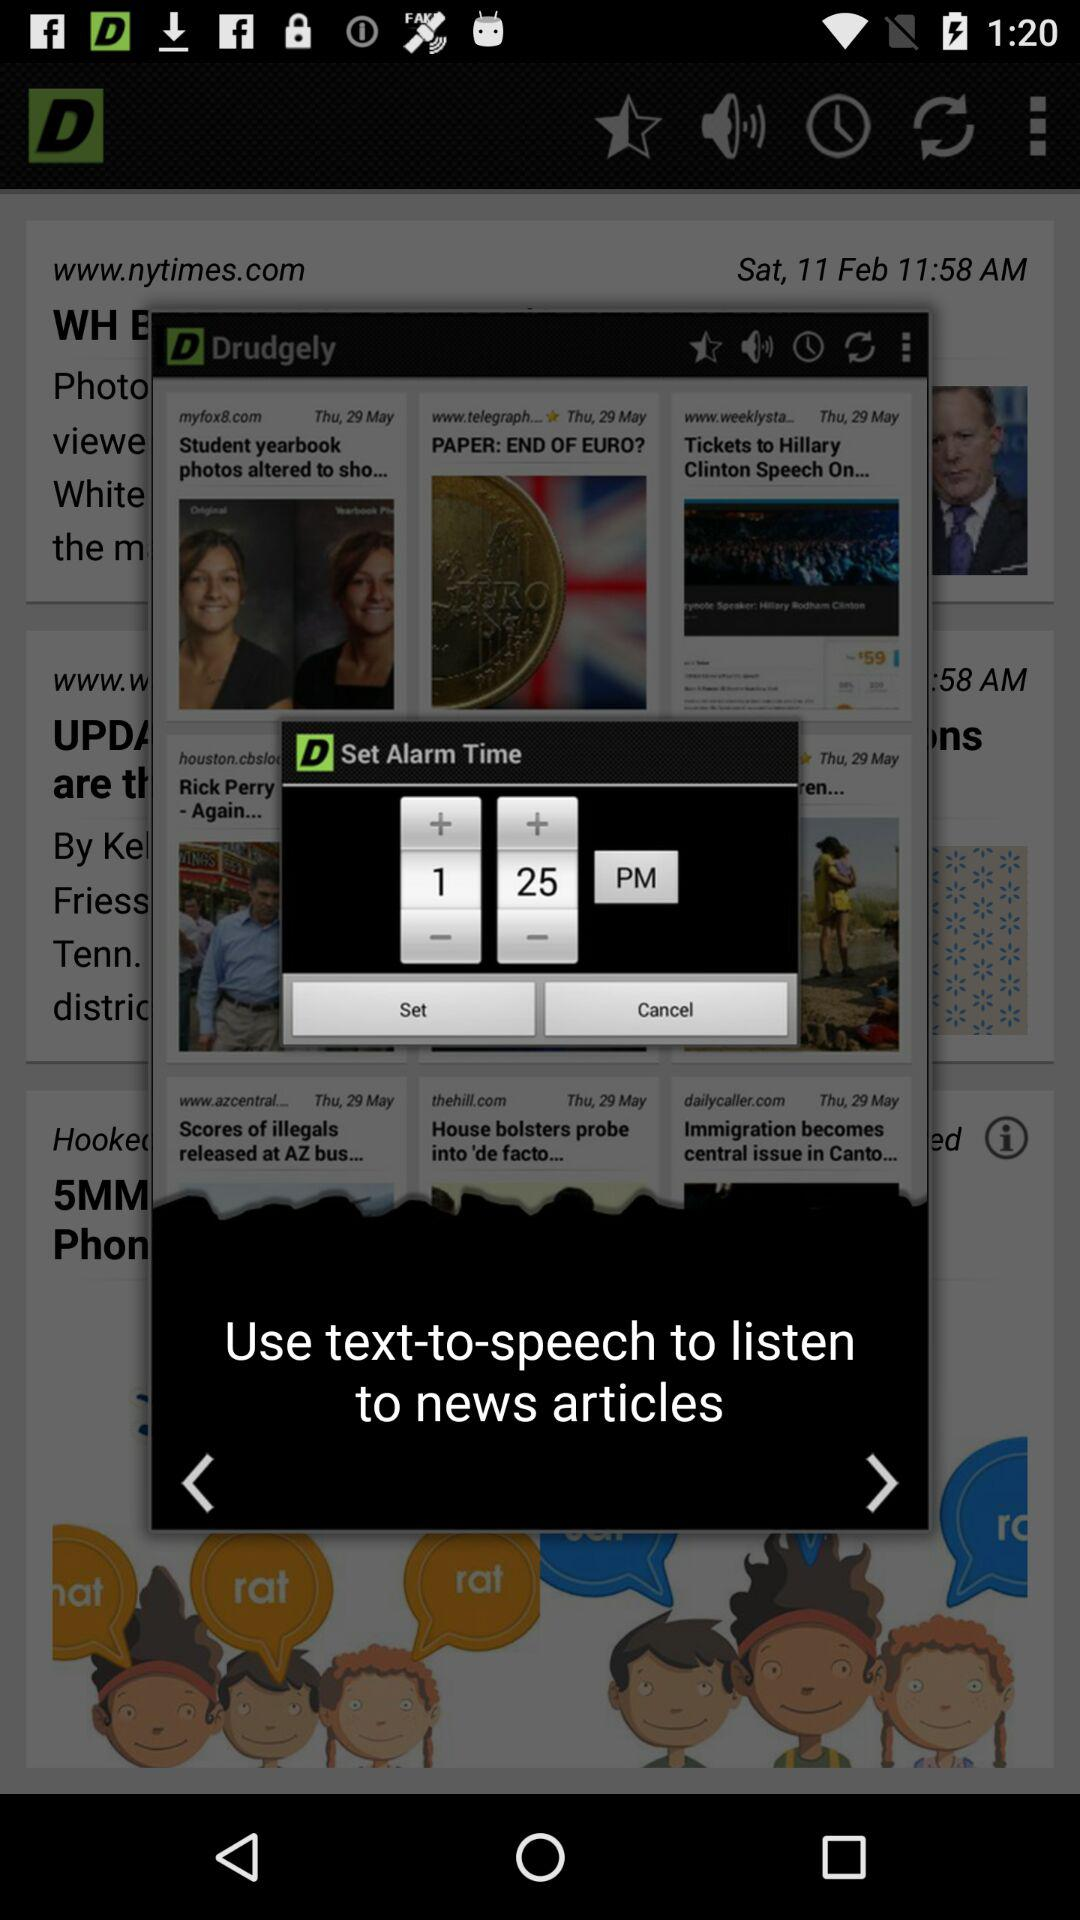What feature is used to listen to news articles? The feature used to listen to news articles is "text-to-speech". 